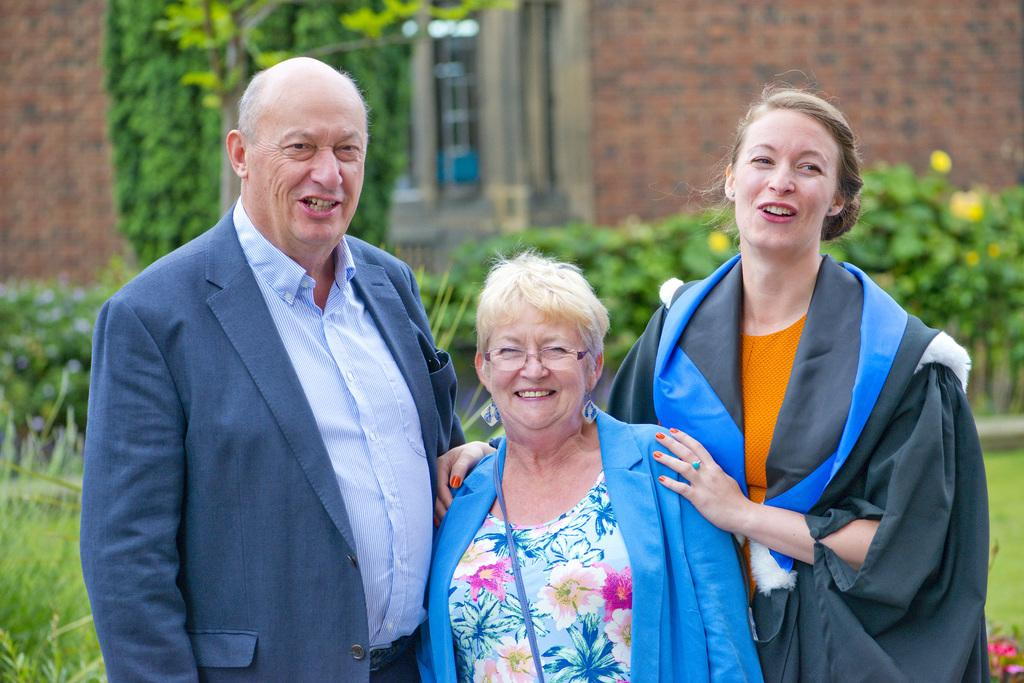How many people are in the foreground of the image? There are two women and a man standing in the foreground of the image. What can be seen in the background of the image? There is greenery and a building with a wall and window visible in the background of the image. What type of crate is being used to control the nation in the image? There is no crate or nation present in the image; it features two women, a man, and a background with greenery and a building. 